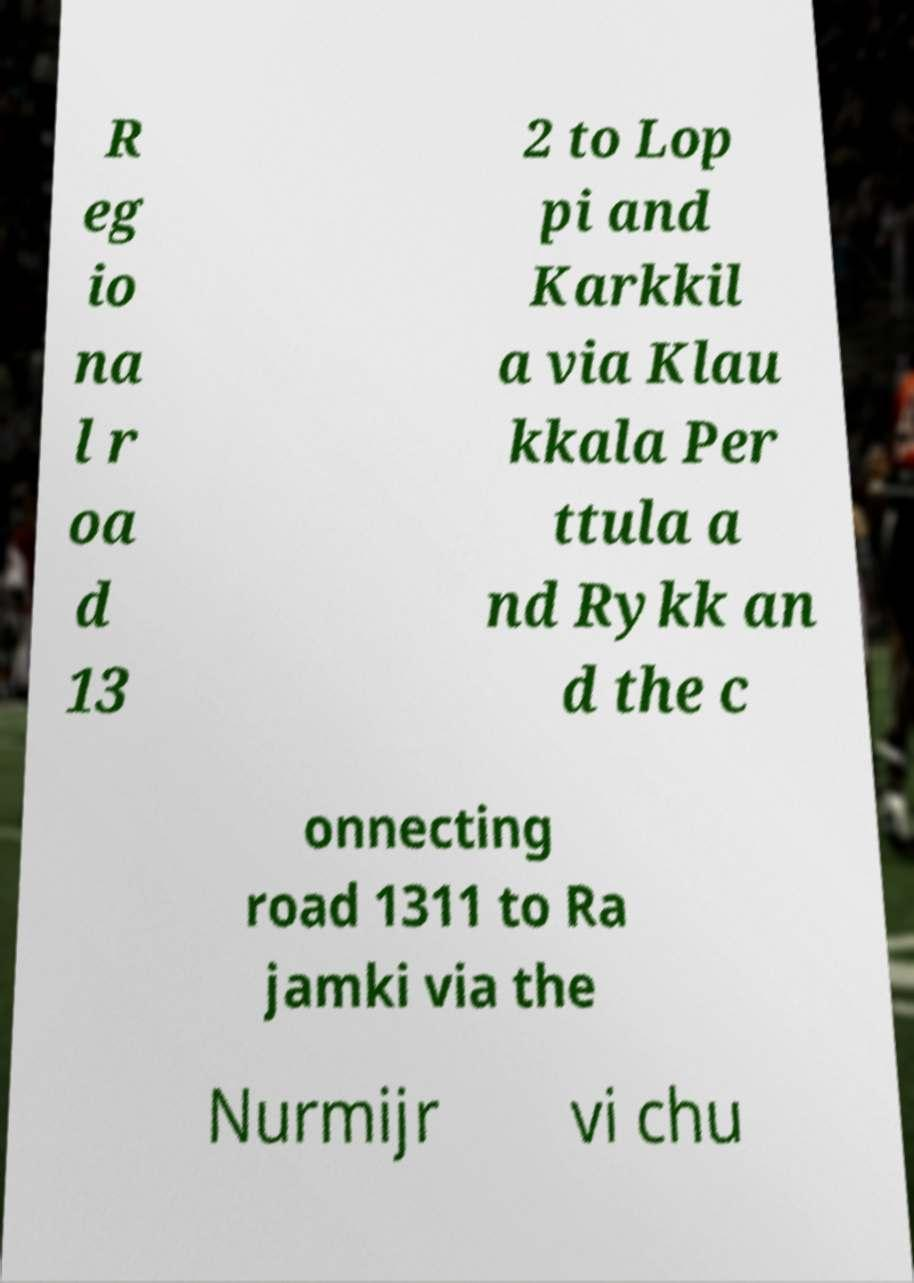For documentation purposes, I need the text within this image transcribed. Could you provide that? R eg io na l r oa d 13 2 to Lop pi and Karkkil a via Klau kkala Per ttula a nd Rykk an d the c onnecting road 1311 to Ra jamki via the Nurmijr vi chu 